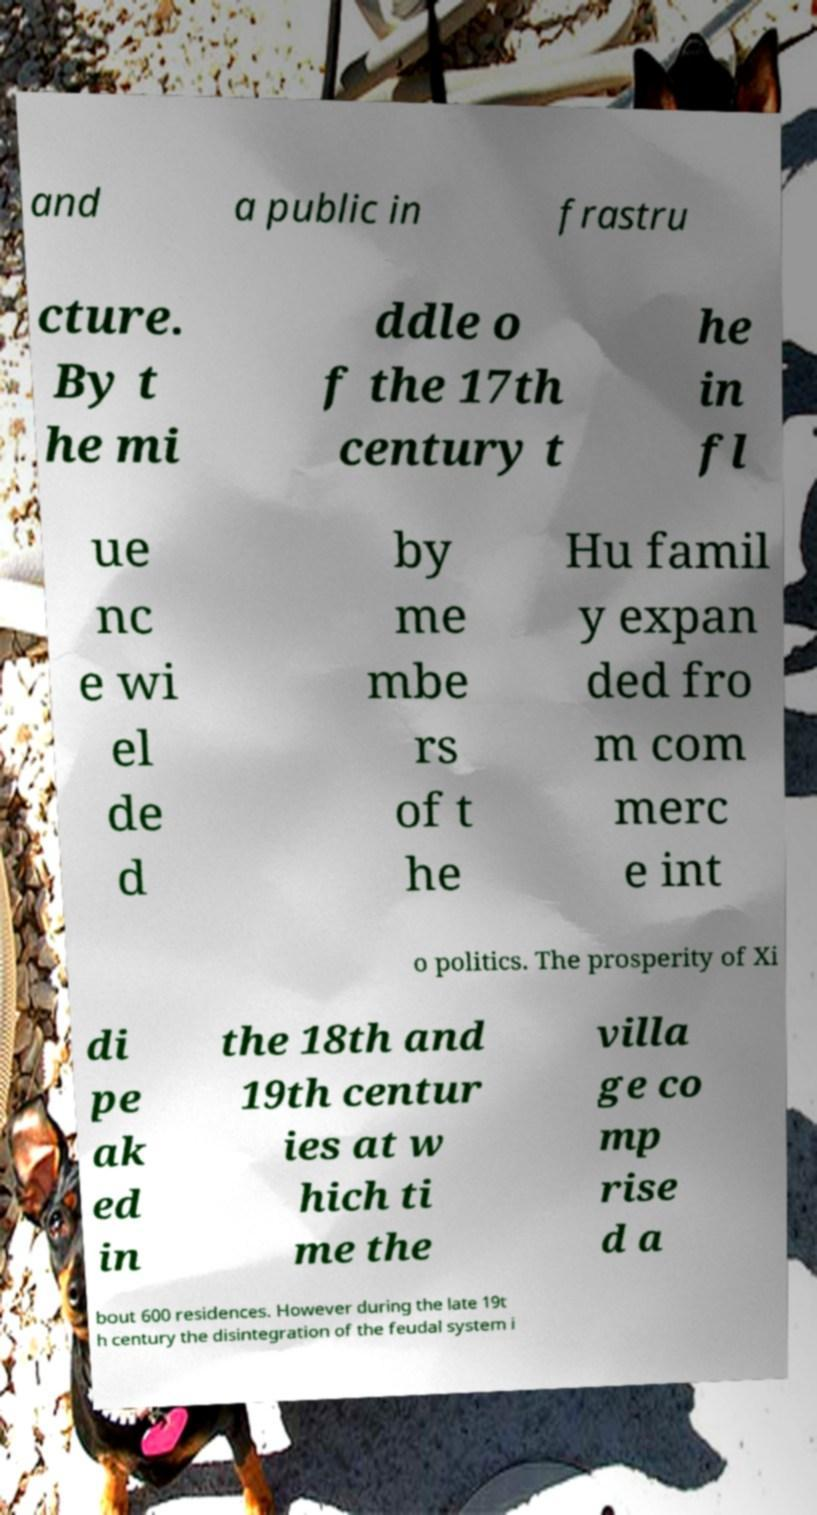Please identify and transcribe the text found in this image. and a public in frastru cture. By t he mi ddle o f the 17th century t he in fl ue nc e wi el de d by me mbe rs of t he Hu famil y expan ded fro m com merc e int o politics. The prosperity of Xi di pe ak ed in the 18th and 19th centur ies at w hich ti me the villa ge co mp rise d a bout 600 residences. However during the late 19t h century the disintegration of the feudal system i 